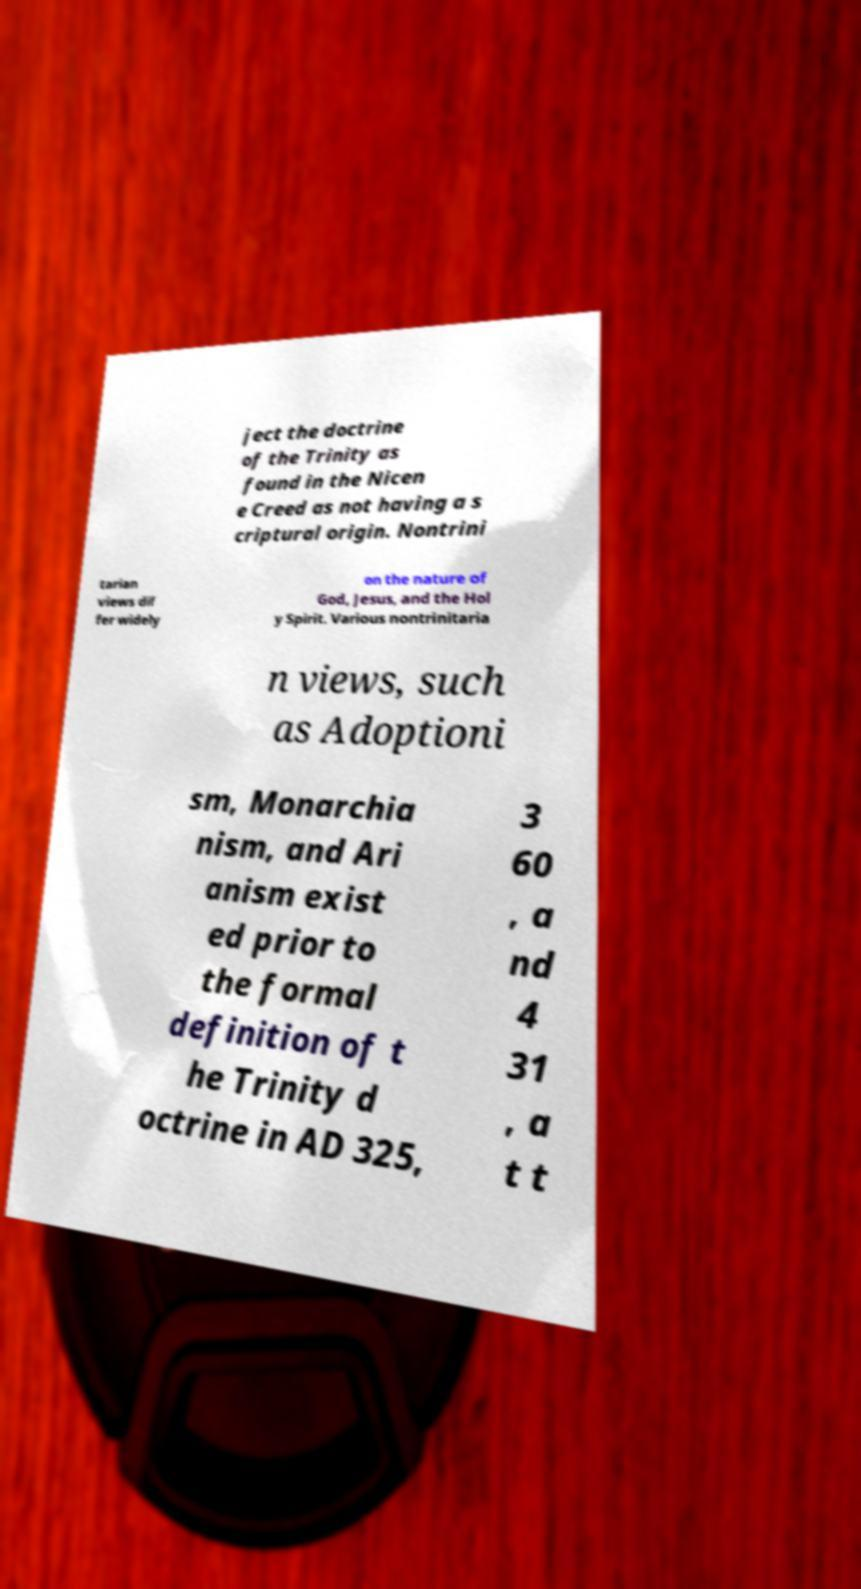There's text embedded in this image that I need extracted. Can you transcribe it verbatim? ject the doctrine of the Trinity as found in the Nicen e Creed as not having a s criptural origin. Nontrini tarian views dif fer widely on the nature of God, Jesus, and the Hol y Spirit. Various nontrinitaria n views, such as Adoptioni sm, Monarchia nism, and Ari anism exist ed prior to the formal definition of t he Trinity d octrine in AD 325, 3 60 , a nd 4 31 , a t t 